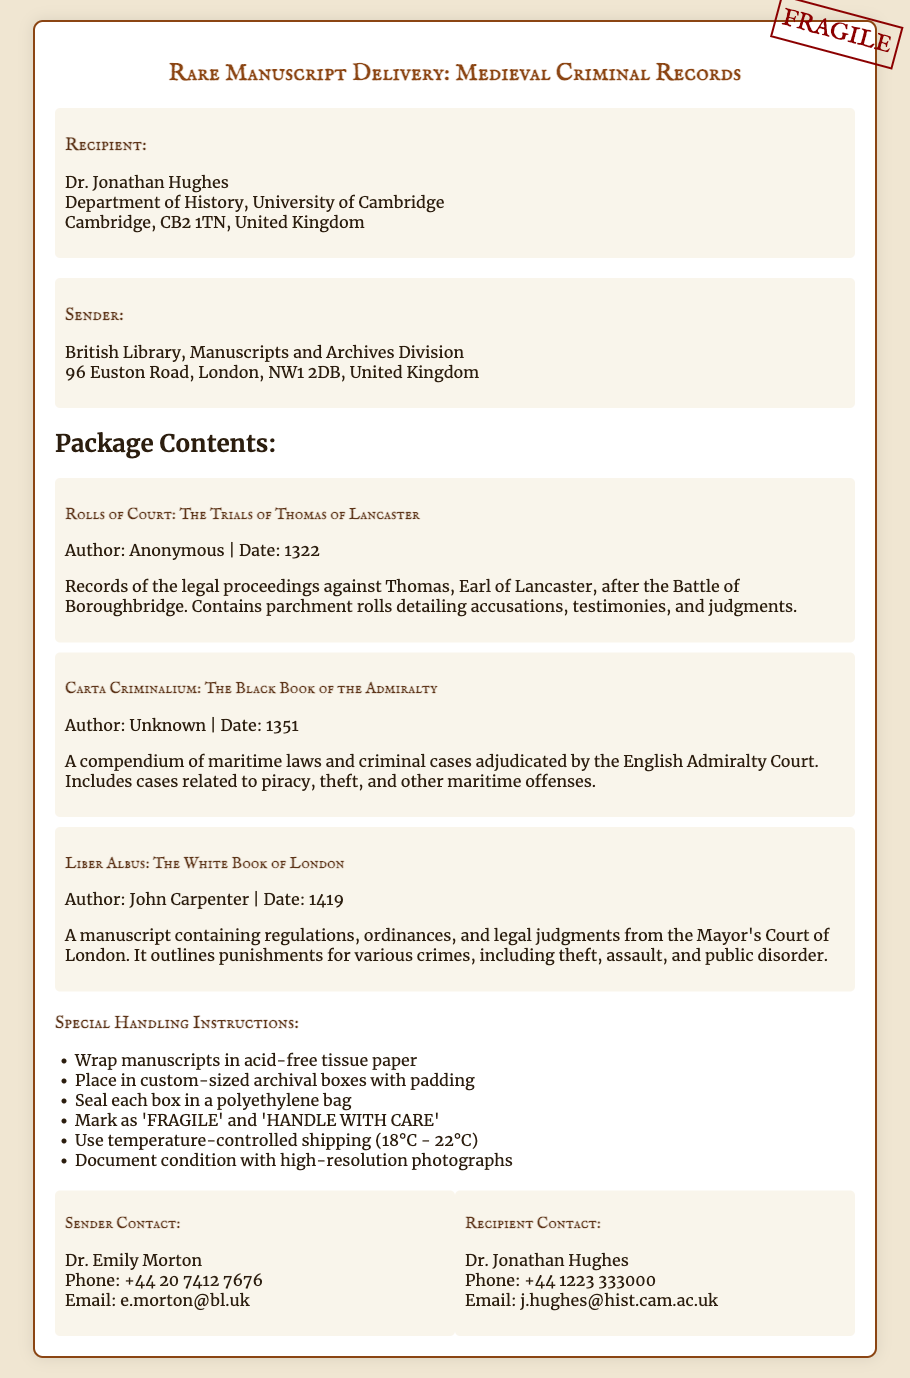What is the title of the manuscripts being delivered? The title of the manuscripts is provided at the top of the document under the main heading.
Answer: Rare Manuscript Delivery: Medieval Criminal Records Who is the recipient of the package? The document lists the recipient's name and contact information in the address section.
Answer: Dr. Jonathan Hughes What is the date of "Liber Albus"? The date associated with this manuscript is found in the package contents section.
Answer: 1419 How many manuscripts are listed in the package? This number can be determined by counting the individual manuscript titles in the package contents.
Answer: Three What special instruction is given regarding the temperature for shipping? The handling instructions specify a temperature range for shipping, which can be found in the special handling instructions section.
Answer: 18°C - 22°C Who authored "Carta Criminalium"? The author of this manuscript is indicated in the package contents section.
Answer: Unknown What is the contact phone number for the sender? The sender's contact information includes a phone number provided in the contact section of the document.
Answer: +44 20 7412 7676 Which manuscript contains maritime laws? This can be found by examining the descriptions of the manuscripts in the package contents section.
Answer: Carta Criminalium: The Black Book of the Admiralty What instruction is given for wrapping manuscripts? The handling instructions outline specific methods for packaging the manuscripts, including wrapping.
Answer: Wrap manuscripts in acid-free tissue paper 